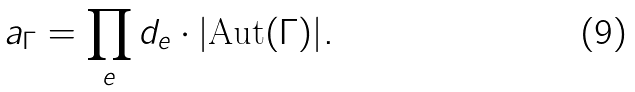Convert formula to latex. <formula><loc_0><loc_0><loc_500><loc_500>a _ { \Gamma } = \prod _ { e } d _ { e } \cdot | \text {Aut} ( \Gamma ) | .</formula> 